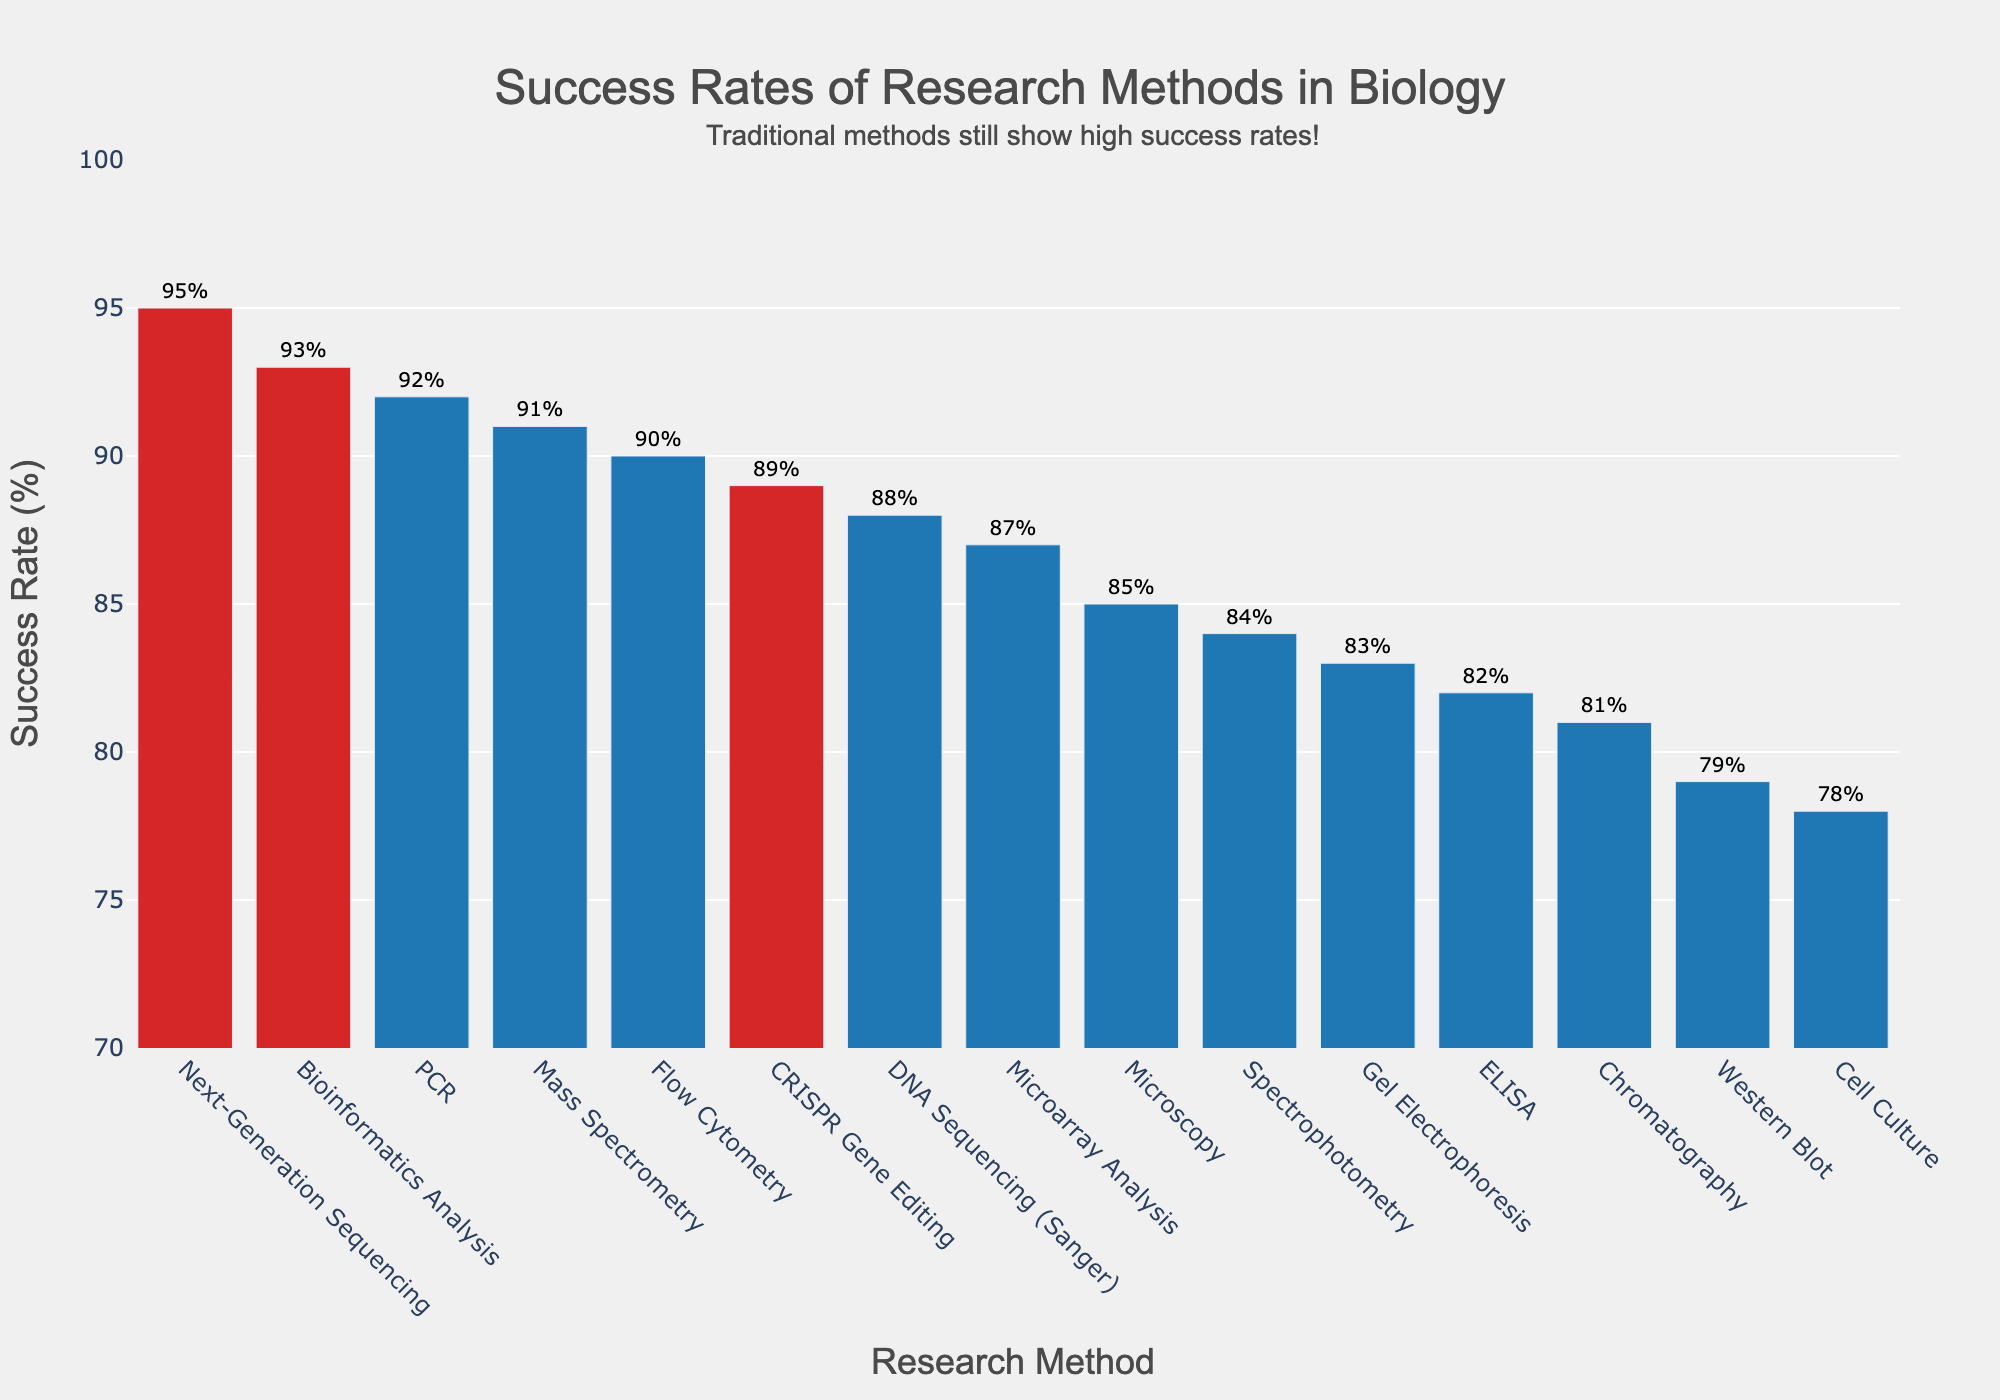Which method has the highest success rate? Look at the bar chart and identify the tallest bar. This bar represents Next-Generation Sequencing with a success rate of 95%.
Answer: Next-Generation Sequencing Which traditional method has the lowest success rate, and what is it? Find the lowest bar among the traditional methods (excluding modern ones like CRISPR, Next-Generation Sequencing, and Bioinformatics). The lowest is Cell Culture, with a success rate of 78%.
Answer: Cell Culture, 78% Compare the success rates of Microscopy and Spectrophotometry. Which one is higher, and by how much? Identify the heights of the bars for Microscopy (85%) and Spectrophotometry (84%). The difference is 85 - 84 = 1%.
Answer: Microscopy is higher by 1% What is the combined success rate of ELISA and Western Blot? Sum the success rates of ELISA (82%) and Western Blot (79%). The combined rate is 82 + 79 = 161%.
Answer: 161% What is the average success rate of traditional methods from the chart? Traditional methods include: Microscopy (85%), PCR (92%), Cell Culture (78%), DNA Sequencing (Sanger) (88%), ELISA (82%), Western Blot (79%), Gel Electrophoresis (83%), Flow Cytometry (90%), Microarray Analysis (87%), Chromatography (81%), Spectrophotometry (84%). Calculate the average (85+92+78+88+82+79+83+90+87+81+84) / 11 = 84.6%.
Answer: 84.6% Which methods are marked with a different color, and what is the significance? Identify bars with a different color (red). These methods are Next-Generation Sequencing, CRISPR Gene Editing, and Bioinformatics Analysis. They represent modern research methods.
Answer: Next-Generation Sequencing, CRISPR Gene Editing, Bioinformatics Analysis By what percentage does Bioinformatics Analysis success rate exceed that of Gel Electrophoresis? Compare the success rates: Bioinformatics Analysis (93%) and Gel Electrophoresis (83%). Calculate the difference: 93 - 83 = 10%.
Answer: 10% Which two methods have success rates closest to each other, and what are those rates? Look for methods with success rates that have the smallest difference between them. PCR (92%) and Mass Spectrometry (91%) are closest, with a difference of 1%.
Answer: PCR and Mass Spectrometry, 92% and 91% How does the success rate of CRISPR Gene Editing compare with traditional DNA Sequencing (Sanger)? Compare the success rates: CRISPR Gene Editing (89%) and DNA Sequencing (Sanger) (88%). CRISPR Gene Editing is higher by 1%.
Answer: CRISPR Gene Editing is higher by 1% What is the success rate of the method immediately following Flow Cytometry? Determine the order by success rate: After Flow Cytometry (90%) comes Bioinformatics Analysis (93%). The method immediately following Flow Cytometry is Bioinformatics Analysis with 93%.
Answer: Bioinformatics Analysis, 93% 